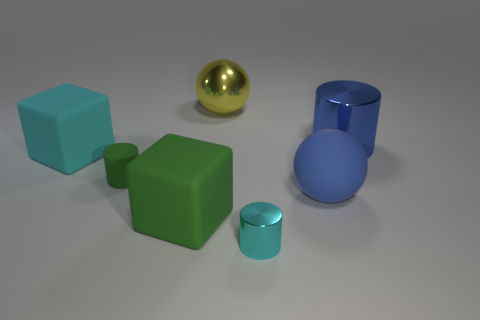Subtract all large metal cylinders. How many cylinders are left? 2 Subtract all green cylinders. How many cylinders are left? 2 Add 3 small yellow shiny cubes. How many objects exist? 10 Subtract all spheres. How many objects are left? 5 Subtract 2 cylinders. How many cylinders are left? 1 Add 6 small metallic objects. How many small metallic objects are left? 7 Add 7 small matte things. How many small matte things exist? 8 Subtract 0 purple balls. How many objects are left? 7 Subtract all green blocks. Subtract all brown cylinders. How many blocks are left? 1 Subtract all cyan cylinders. How many brown balls are left? 0 